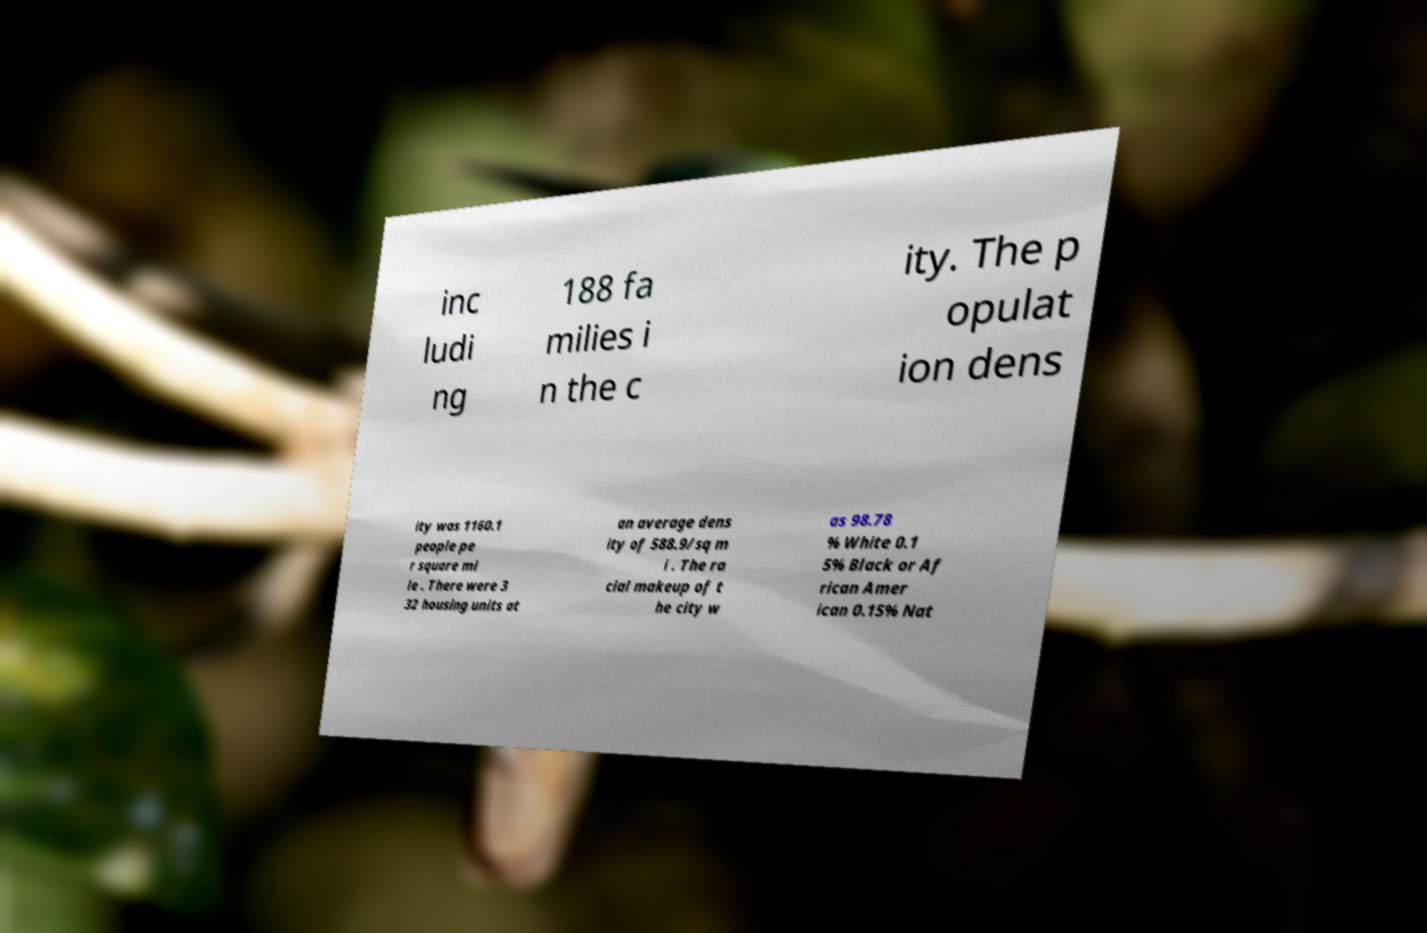Please read and relay the text visible in this image. What does it say? inc ludi ng 188 fa milies i n the c ity. The p opulat ion dens ity was 1160.1 people pe r square mi le . There were 3 32 housing units at an average dens ity of 588.9/sq m i . The ra cial makeup of t he city w as 98.78 % White 0.1 5% Black or Af rican Amer ican 0.15% Nat 